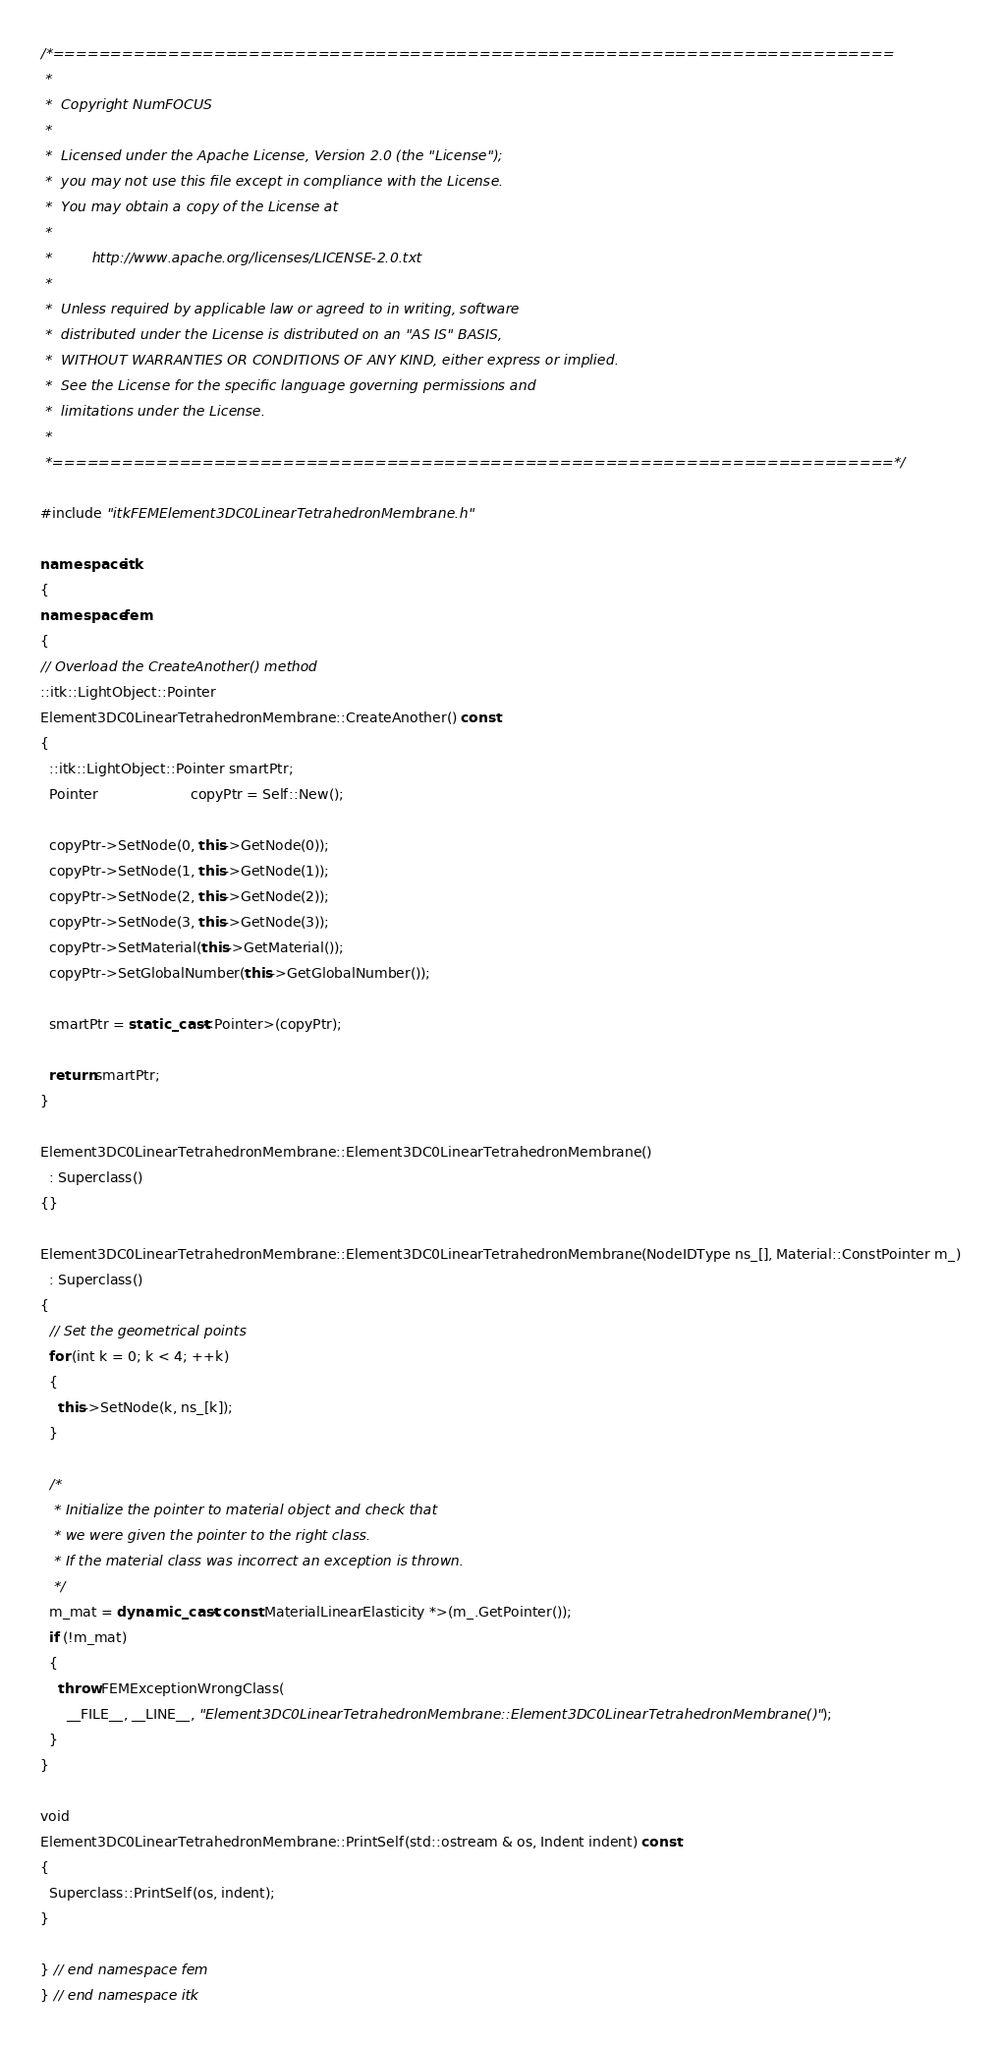<code> <loc_0><loc_0><loc_500><loc_500><_C++_>/*=========================================================================
 *
 *  Copyright NumFOCUS
 *
 *  Licensed under the Apache License, Version 2.0 (the "License");
 *  you may not use this file except in compliance with the License.
 *  You may obtain a copy of the License at
 *
 *         http://www.apache.org/licenses/LICENSE-2.0.txt
 *
 *  Unless required by applicable law or agreed to in writing, software
 *  distributed under the License is distributed on an "AS IS" BASIS,
 *  WITHOUT WARRANTIES OR CONDITIONS OF ANY KIND, either express or implied.
 *  See the License for the specific language governing permissions and
 *  limitations under the License.
 *
 *=========================================================================*/

#include "itkFEMElement3DC0LinearTetrahedronMembrane.h"

namespace itk
{
namespace fem
{
// Overload the CreateAnother() method
::itk::LightObject::Pointer
Element3DC0LinearTetrahedronMembrane::CreateAnother() const
{
  ::itk::LightObject::Pointer smartPtr;
  Pointer                     copyPtr = Self::New();

  copyPtr->SetNode(0, this->GetNode(0));
  copyPtr->SetNode(1, this->GetNode(1));
  copyPtr->SetNode(2, this->GetNode(2));
  copyPtr->SetNode(3, this->GetNode(3));
  copyPtr->SetMaterial(this->GetMaterial());
  copyPtr->SetGlobalNumber(this->GetGlobalNumber());

  smartPtr = static_cast<Pointer>(copyPtr);

  return smartPtr;
}

Element3DC0LinearTetrahedronMembrane::Element3DC0LinearTetrahedronMembrane()
  : Superclass()
{}

Element3DC0LinearTetrahedronMembrane::Element3DC0LinearTetrahedronMembrane(NodeIDType ns_[], Material::ConstPointer m_)
  : Superclass()
{
  // Set the geometrical points
  for (int k = 0; k < 4; ++k)
  {
    this->SetNode(k, ns_[k]);
  }

  /*
   * Initialize the pointer to material object and check that
   * we were given the pointer to the right class.
   * If the material class was incorrect an exception is thrown.
   */
  m_mat = dynamic_cast<const MaterialLinearElasticity *>(m_.GetPointer());
  if (!m_mat)
  {
    throw FEMExceptionWrongClass(
      __FILE__, __LINE__, "Element3DC0LinearTetrahedronMembrane::Element3DC0LinearTetrahedronMembrane()");
  }
}

void
Element3DC0LinearTetrahedronMembrane::PrintSelf(std::ostream & os, Indent indent) const
{
  Superclass::PrintSelf(os, indent);
}

} // end namespace fem
} // end namespace itk
</code> 